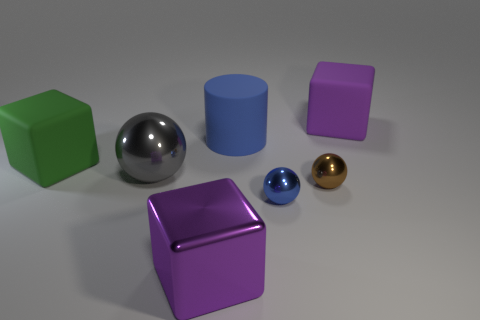There is a ball left of the purple metal thing; is its color the same as the rubber cylinder?
Offer a very short reply. No. There is a brown thing that is the same size as the blue shiny ball; what is its shape?
Give a very brief answer. Sphere. What number of other things are there of the same color as the large cylinder?
Keep it short and to the point. 1. How many other things are the same material as the big sphere?
Offer a very short reply. 3. There is a purple shiny object; is it the same size as the rubber cube to the right of the tiny blue metallic ball?
Keep it short and to the point. Yes. The big cylinder is what color?
Your answer should be very brief. Blue. What shape is the big purple thing in front of the gray metallic sphere left of the purple thing in front of the large green rubber object?
Give a very brief answer. Cube. What is the material of the large purple object that is in front of the large purple cube behind the metal cube?
Give a very brief answer. Metal. There is a big blue object that is made of the same material as the green thing; what shape is it?
Give a very brief answer. Cylinder. Is there any other thing that is the same shape as the brown shiny object?
Keep it short and to the point. Yes. 